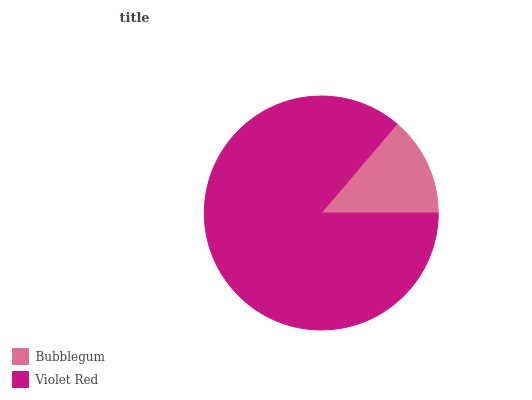Is Bubblegum the minimum?
Answer yes or no. Yes. Is Violet Red the maximum?
Answer yes or no. Yes. Is Violet Red the minimum?
Answer yes or no. No. Is Violet Red greater than Bubblegum?
Answer yes or no. Yes. Is Bubblegum less than Violet Red?
Answer yes or no. Yes. Is Bubblegum greater than Violet Red?
Answer yes or no. No. Is Violet Red less than Bubblegum?
Answer yes or no. No. Is Violet Red the high median?
Answer yes or no. Yes. Is Bubblegum the low median?
Answer yes or no. Yes. Is Bubblegum the high median?
Answer yes or no. No. Is Violet Red the low median?
Answer yes or no. No. 